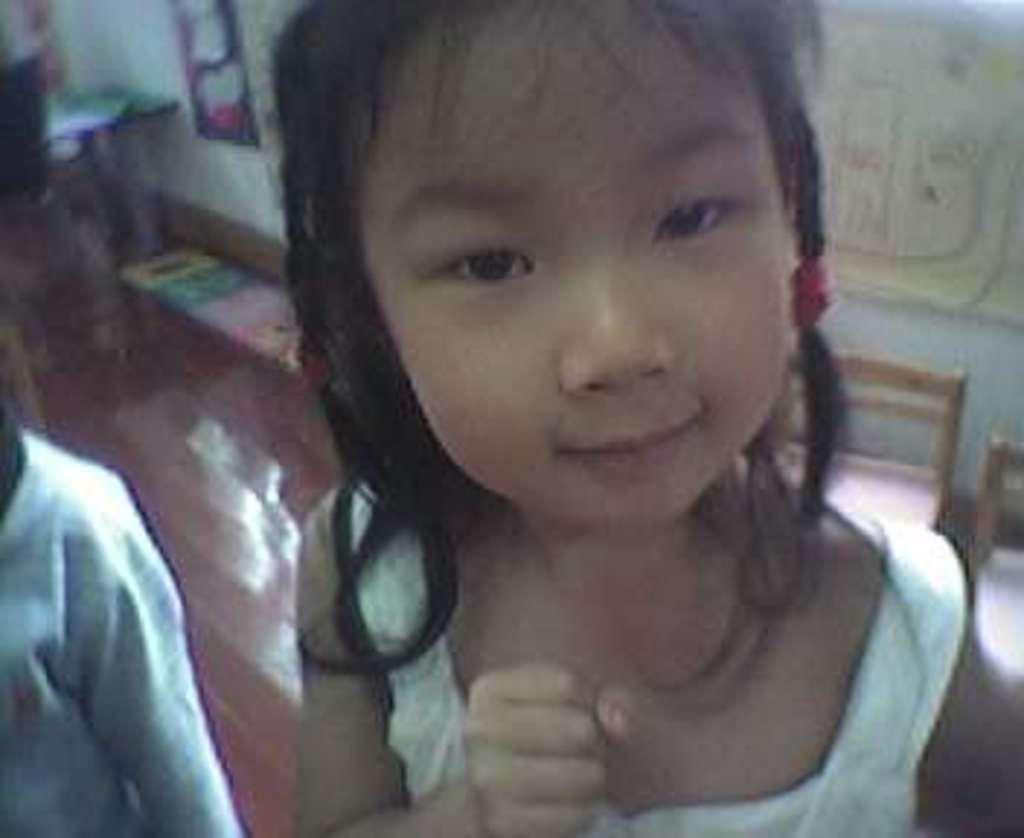Who is the main subject in the image? There is a girl in the image. Where is the other person located in the image? There is a person on the left side of the image. What type of objects can be seen on the ground in the image? There are colorful objects on the ground in the image. What type of objects can be seen on the wall in the image? There are colorful objects on the wall in the image. How would you describe the quality of the image? The image is blurry. What is the girl teaching in the image? There is no indication in the image that the girl is teaching anything. 